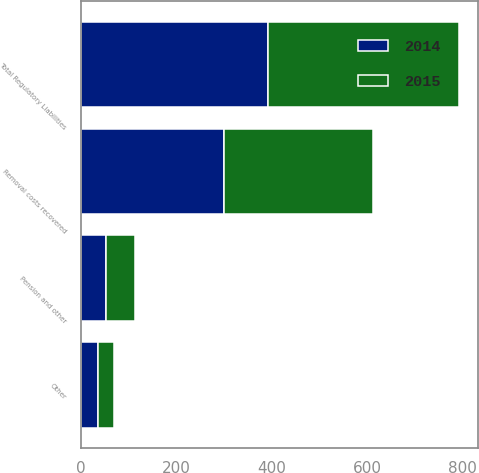Convert chart. <chart><loc_0><loc_0><loc_500><loc_500><stacked_bar_chart><ecel><fcel>Removal costs recovered<fcel>Pension and other<fcel>Other<fcel>Total Regulatory Liabilities<nl><fcel>2015<fcel>311<fcel>59<fcel>32<fcel>402<nl><fcel>2014<fcel>301<fcel>54<fcel>37<fcel>392<nl></chart> 